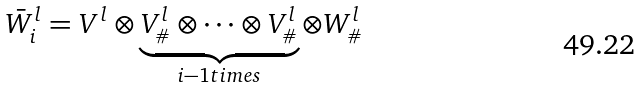<formula> <loc_0><loc_0><loc_500><loc_500>\bar { W } _ { i } ^ { l } = V ^ { l } \otimes \underbrace { V ^ { l } _ { \# } \otimes \dots \otimes V ^ { l } _ { \# } } _ { i - 1 t i m e s } \otimes W ^ { l } _ { \# }</formula> 